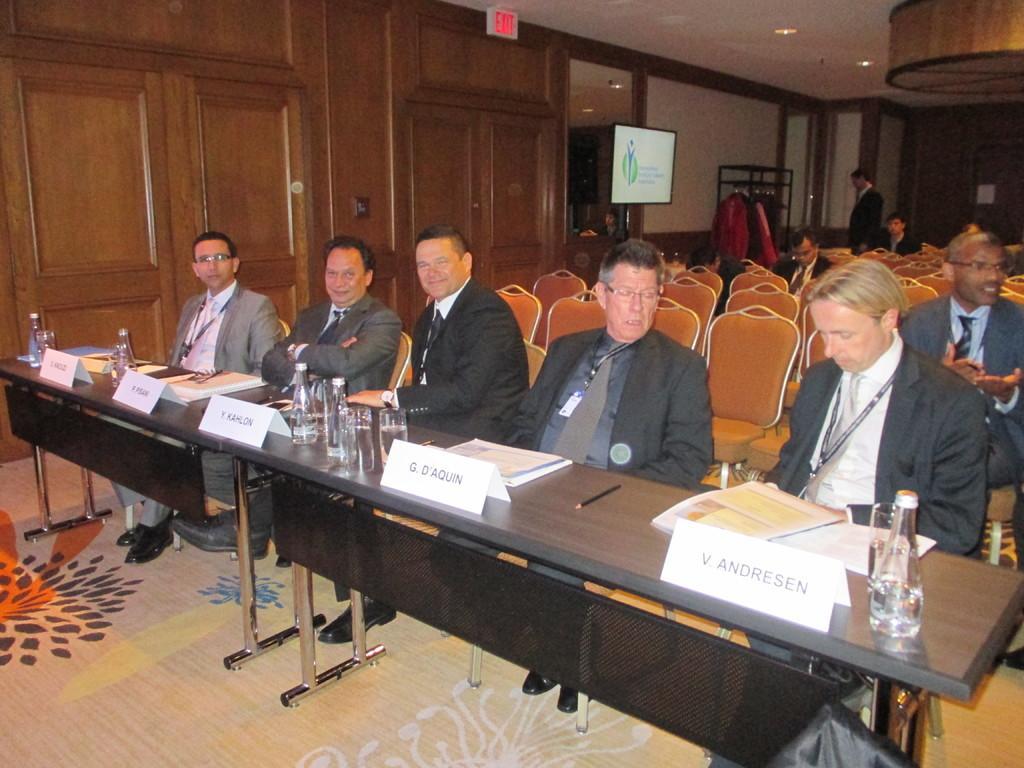How would you summarize this image in a sentence or two? In this image I can see the ground and on the ground I can see few tables and on the table I can see few glasses, few bottles and few white colored boards. I can see few persons wearing black colored blazers are sitting on chairs. In the background I can see few persons sitting, few persons standing, the wall, a television, the ceiling and few lights to the ceiling. 